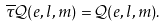Convert formula to latex. <formula><loc_0><loc_0><loc_500><loc_500>\overline { \tau } \mathcal { Q } ( e , l , m ) = \mathcal { Q } ( e , l , m ) .</formula> 